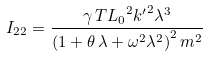Convert formula to latex. <formula><loc_0><loc_0><loc_500><loc_500>I _ { 2 2 } = { \frac { \gamma \, T { L _ { 0 } } ^ { 2 } { k ^ { \prime } } ^ { 2 } { \lambda } ^ { 3 } } { \left ( 1 + \theta \, \lambda + { \omega } ^ { 2 } { \lambda } ^ { 2 } \right ) ^ { 2 } { m } ^ { 2 } } }</formula> 